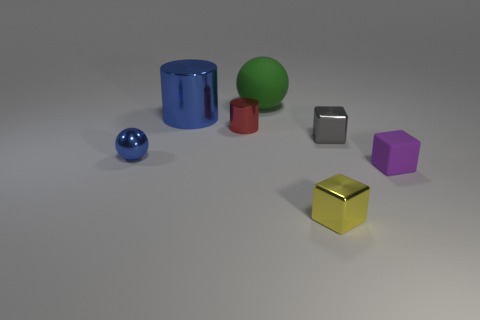What number of objects are purple rubber cubes or gray shiny cubes?
Make the answer very short. 2. Are there any small metallic balls that have the same color as the large shiny object?
Make the answer very short. Yes. There is a blue object behind the small gray thing; how many small shiny objects are on the left side of it?
Provide a succinct answer. 1. Are there more small purple rubber things than green metallic cylinders?
Give a very brief answer. Yes. Do the tiny yellow block and the small cylinder have the same material?
Your answer should be compact. Yes. Are there an equal number of large green rubber spheres that are in front of the tiny red metal cylinder and cyan shiny cylinders?
Ensure brevity in your answer.  Yes. How many small purple cubes have the same material as the small red cylinder?
Your response must be concise. 0. Is the number of blue things less than the number of blue balls?
Your response must be concise. No. There is a small metal cube that is behind the small purple matte block; is its color the same as the large cylinder?
Keep it short and to the point. No. What number of small objects are behind the small metal thing on the right side of the thing in front of the matte cube?
Make the answer very short. 1. 